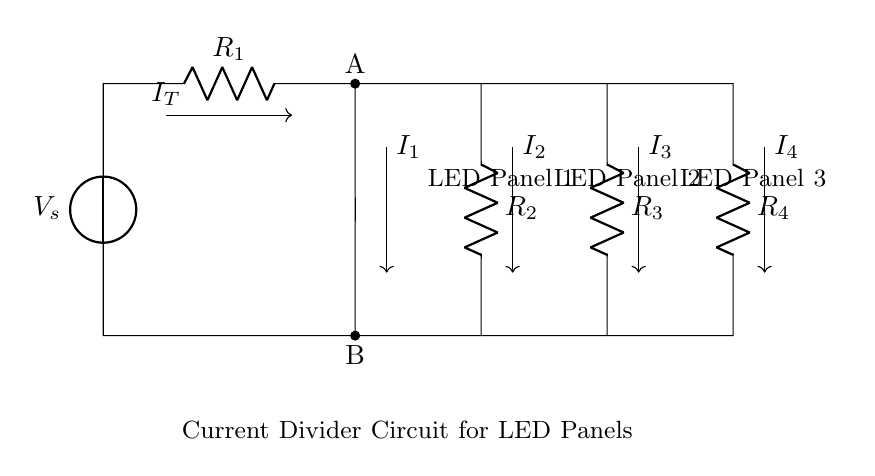What is the total current flowing into the circuit? The total current entering the circuit is represented by I_T, which is the combined current that divides among the resistors in the parallel configuration.
Answer: I_T Which component has the highest resistance? The resistance values R_1, R_2, R_3, and R_4 are not explicitly given in the diagram, but they are labeled as individual resistors. To determine the highest resistance, one would typically compare their numeric values if provided; otherwise, no conclusion can be drawn from the circuit alone.
Answer: Cannot determine How many LED panels are connected in the circuit? The circuit shows three LED panels connected parallelly after the resistors, indicated by the labels near the respective connecting lines.
Answer: Three What is the branching point of the current in the circuit? The branching point is point A, where the total incoming current I_T splits into the different paths leading to the various resistors and LED panels.
Answer: A What is the purpose of the resistors in this circuit? The resistors serve to limit the current flowing to each LED panel. By having them in the circuit, each LED can receive an appropriate amount of current based on its requirement, ensuring they do not get damaged due to excess current.
Answer: Current limiting Which point is the ground reference in the circuit? Point B, located at the bottom of the voltage source and serving as the return path for the current, acts as the ground reference in this circuit configuration.
Answer: B 